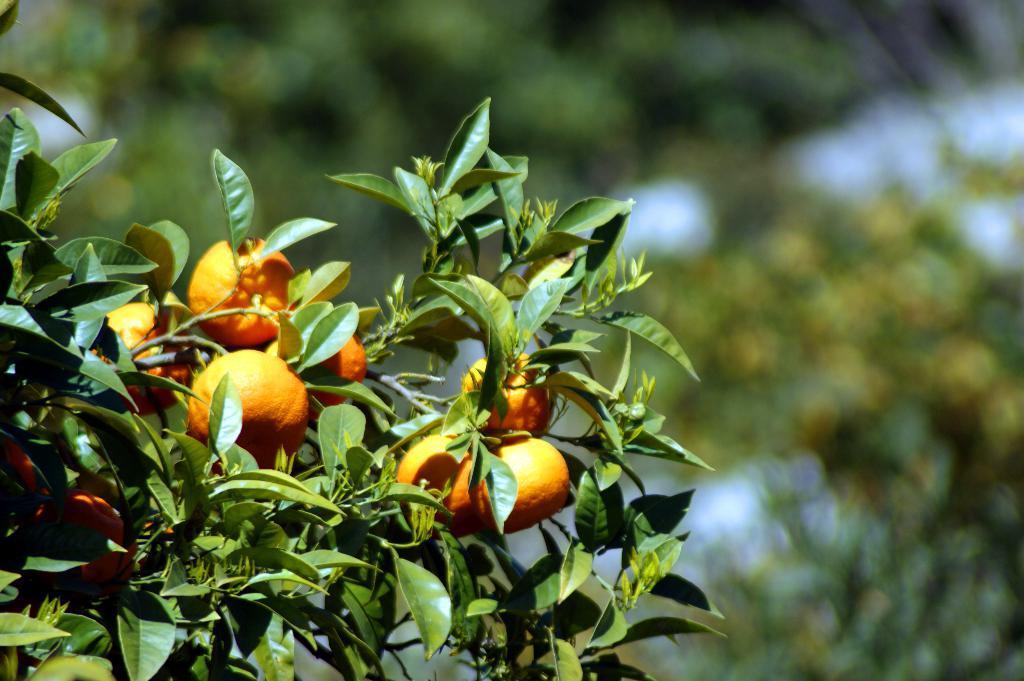Describe this image in one or two sentences. In the foreground of this image, there are oranges to the tree and the background image is blur. 